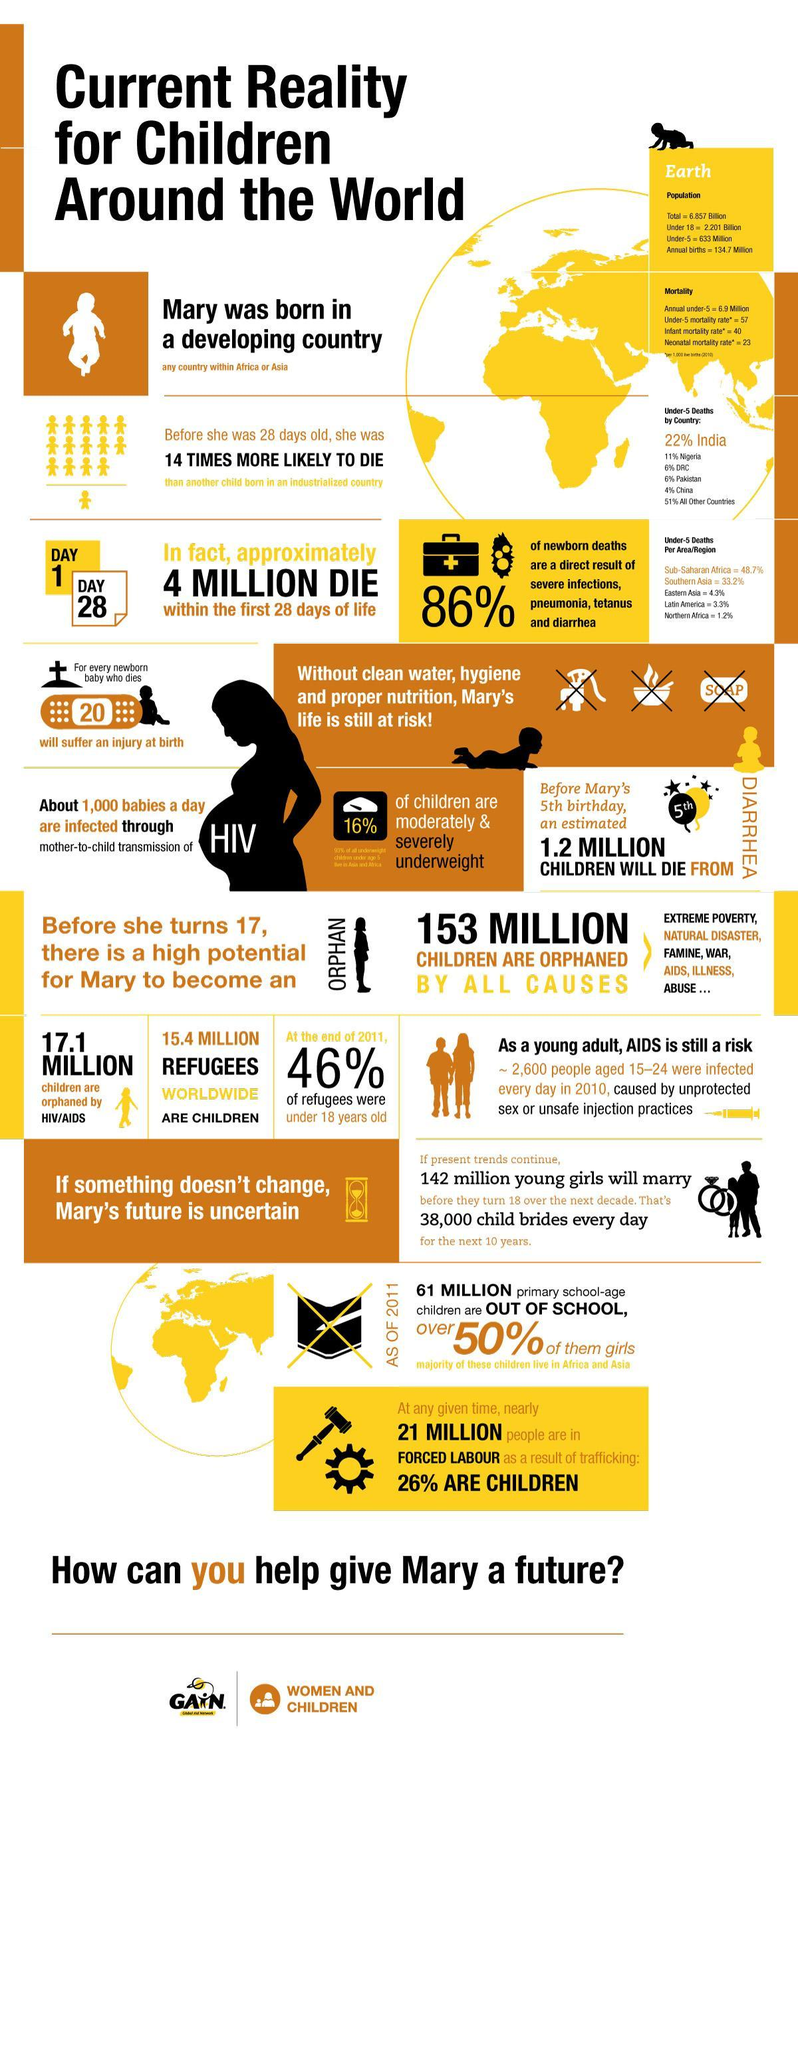Which region in the world reported the least percent of deaths of children under 5?
Answer the question with a short phrase. Northern Africa Which region in the world reported the highest percent of deaths of children under 5? Sub-Saharan Africa How many child refugees are there worldwide? 15.4 MILLION What is the infant mortality rate per 1000 live births in 2010? 40 What percent of children are in forced labour as a result of trafficking? 26% What percent of refugees were under 18 years old at the end of 2011? 46% What percentage of newborn deaths are as a result of severe infections, pneumonia, tetanus & diarrhoea? 86% What is the percentage of deaths of children under 5 in Nigeria? 11% How many children are orphaned by HIV/AIDS worldwide? 17.1 MILLION What is the percentage of deaths of children under 5 in Pakistan? 6% 